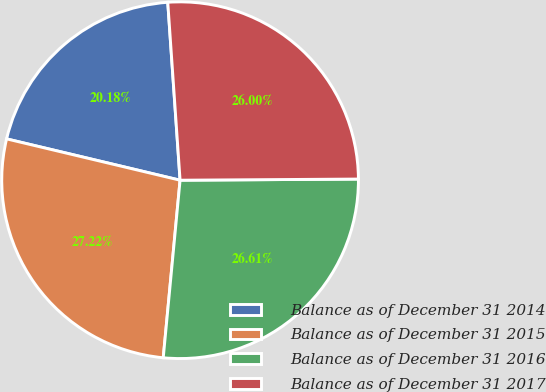<chart> <loc_0><loc_0><loc_500><loc_500><pie_chart><fcel>Balance as of December 31 2014<fcel>Balance as of December 31 2015<fcel>Balance as of December 31 2016<fcel>Balance as of December 31 2017<nl><fcel>20.18%<fcel>27.22%<fcel>26.61%<fcel>26.0%<nl></chart> 